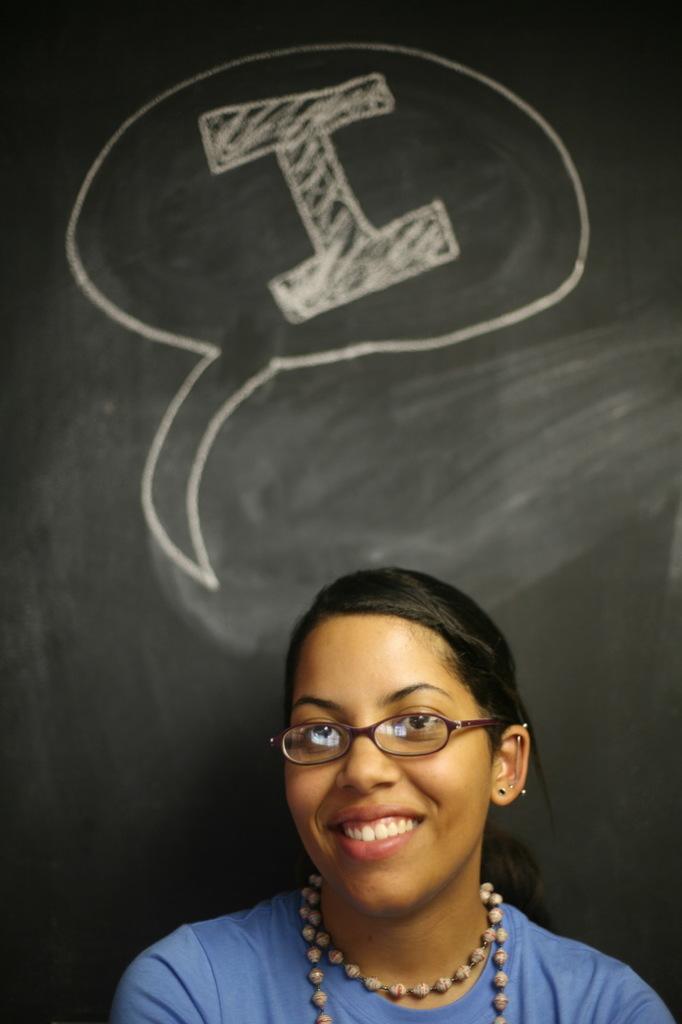In one or two sentences, can you explain what this image depicts? In the front of the image I can see a woman smiling and wearing spectacles. In the background of the image there is a black board. Something is written on the blackboard.  